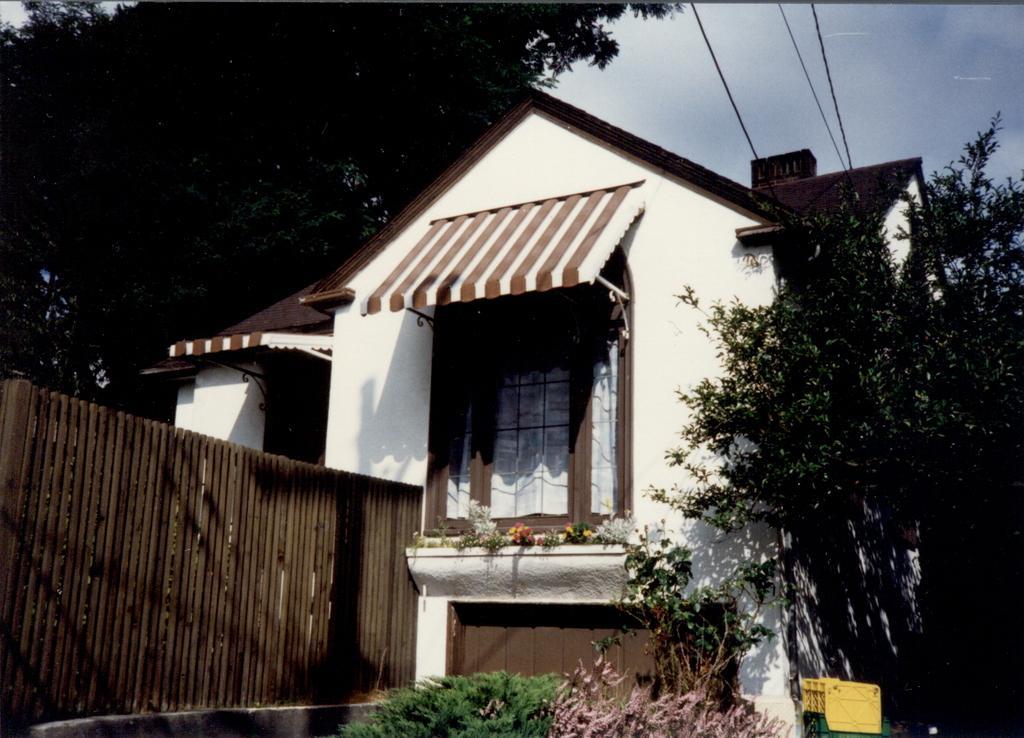Describe this image in one or two sentences. In this image I can see a house which is white in color, the railing, few trees which are green in color, few windows, a yellow colored object and few wires. In the background I can see few trees and the sky. 